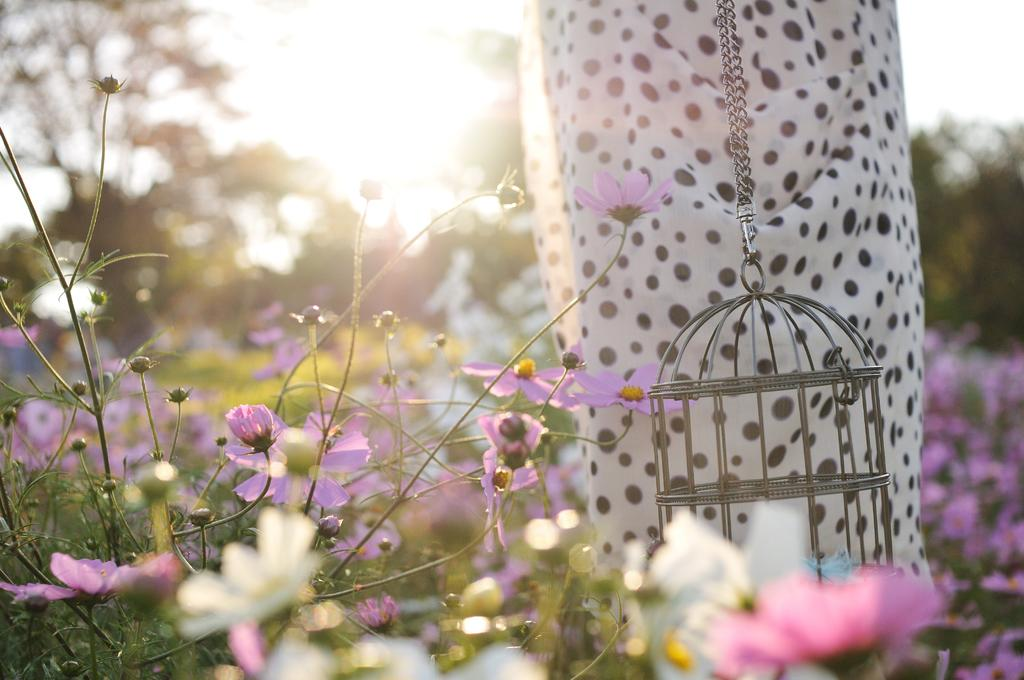What types of living organisms can be seen in the image? Plants and flowers are visible in the image. What structure is located behind the plants? There is a bird cage behind the plants. What is located behind the bird cage? There is an object behind the bird cage. What can be seen in the background of the image? Trees are visible in the background of the image. What type of volleyball is being played in the image? There is no volleyball present in the image. How does the love between the plants and flowers manifest in the image? The image does not depict any emotions or relationships between the plants and flowers. 